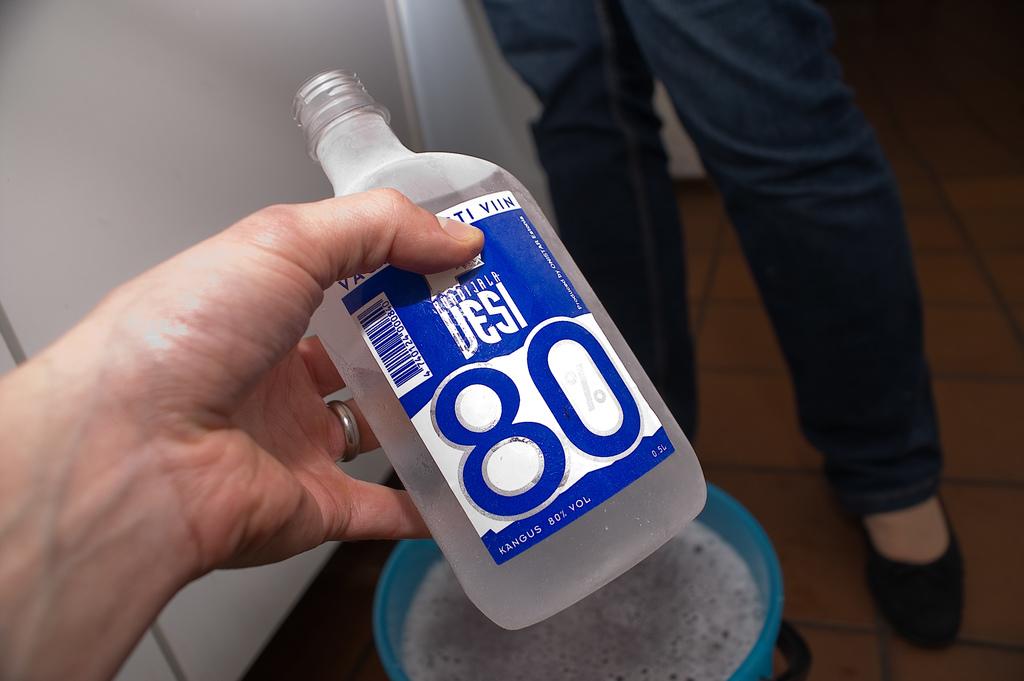What number is on the bottle?
Ensure brevity in your answer.  80. What percentage of alcohol is in this bottle?
Make the answer very short. 80. 